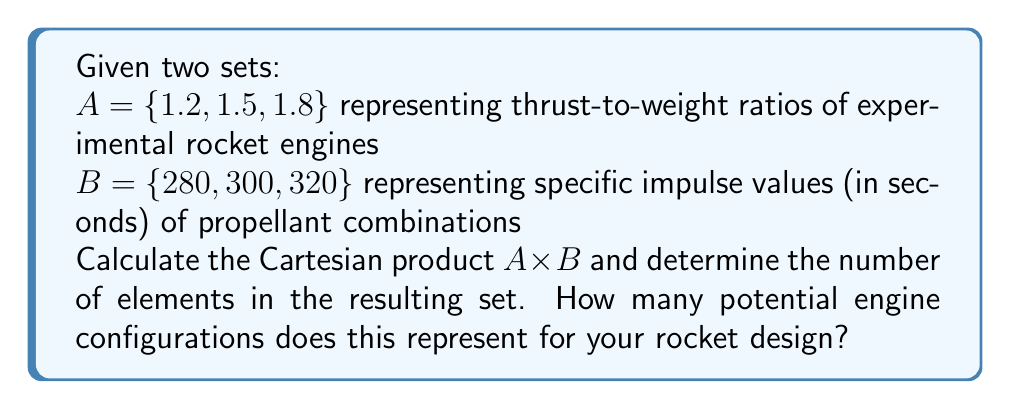Could you help me with this problem? To solve this problem, we need to understand the concept of Cartesian product and apply it to the given sets.

1) The Cartesian product of two sets $A$ and $B$, denoted as $A \times B$, is the set of all ordered pairs $(a,b)$ where $a \in A$ and $b \in B$.

2) For our sets:
   $A = \{1.2, 1.5, 1.8\}$
   $B = \{280, 300, 320\}$

3) The Cartesian product $A \times B$ will be:

   $A \times B = \{(1.2, 280), (1.2, 300), (1.2, 320),$
                 $(1.5, 280), (1.5, 300), (1.5, 320),$
                 $(1.8, 280), (1.8, 300), (1.8, 320)\}$

4) To determine the number of elements in $A \times B$, we can use the multiplication principle:
   
   $|A \times B| = |A| \cdot |B|$

   Where $|A|$ is the number of elements in set $A$, and $|B|$ is the number of elements in set $B$.

5) In this case:
   $|A| = 3$ and $|B| = 3$

6) Therefore:
   $|A \times B| = 3 \cdot 3 = 9$

Each element in the Cartesian product represents a potential engine configuration, combining a specific thrust-to-weight ratio with a specific impulse value.
Answer: The Cartesian product $A \times B$ has 9 elements, representing 9 potential engine configurations for the rocket design. 